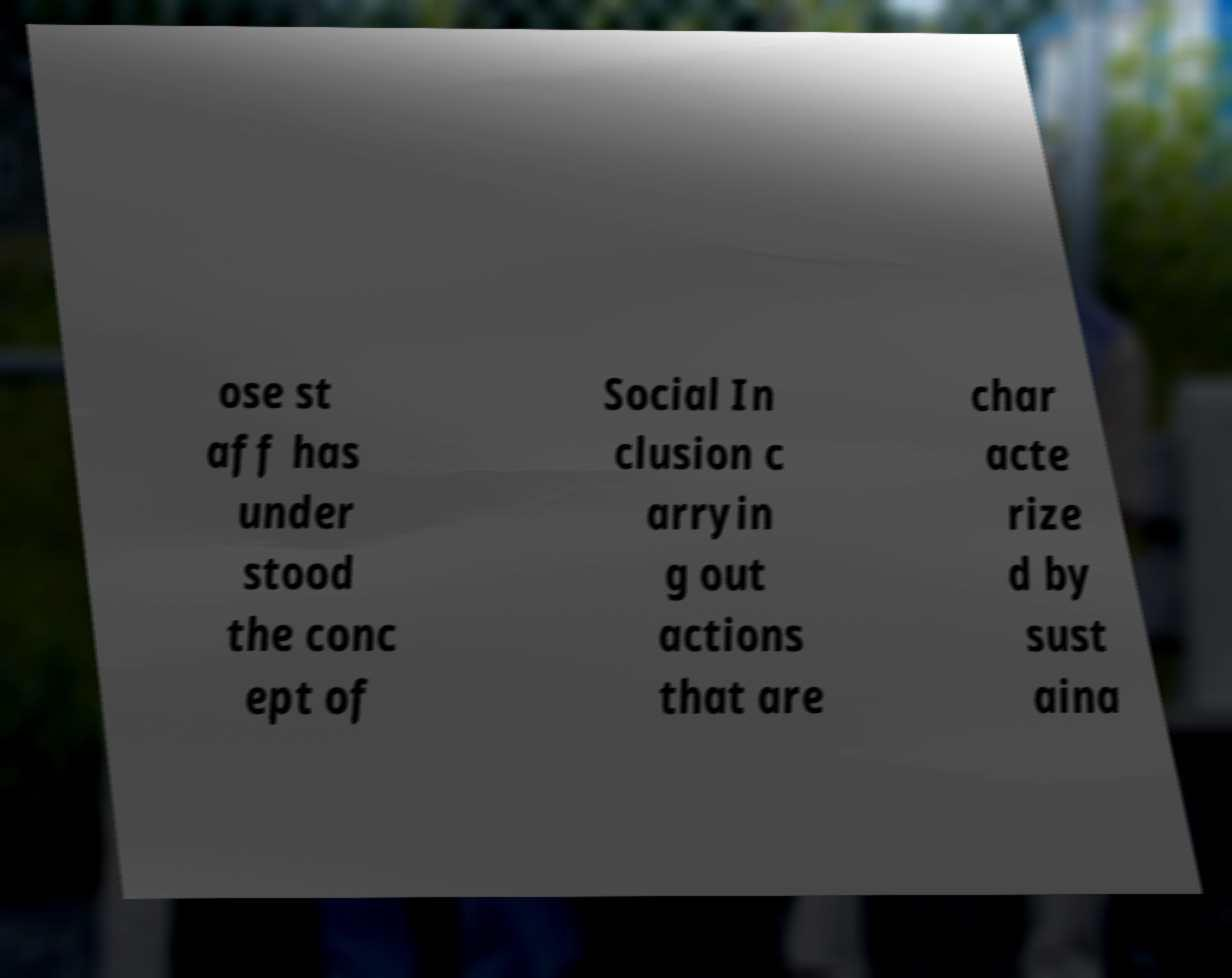Please identify and transcribe the text found in this image. ose st aff has under stood the conc ept of Social In clusion c arryin g out actions that are char acte rize d by sust aina 